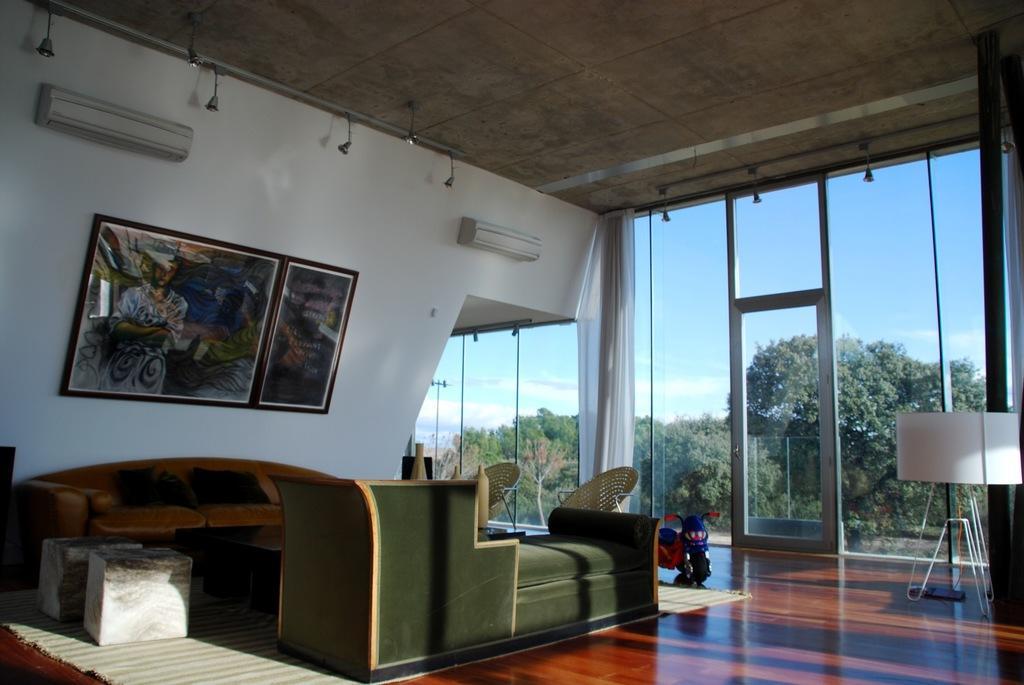Can you describe this image briefly? In the middle of the image there are some couches and chairs. At the top of the image there is roof and wall, on the wall there are some frames. On the top right side of the image there is a glass wall. Through the glass wall we can see some trees and clouds and sky. 